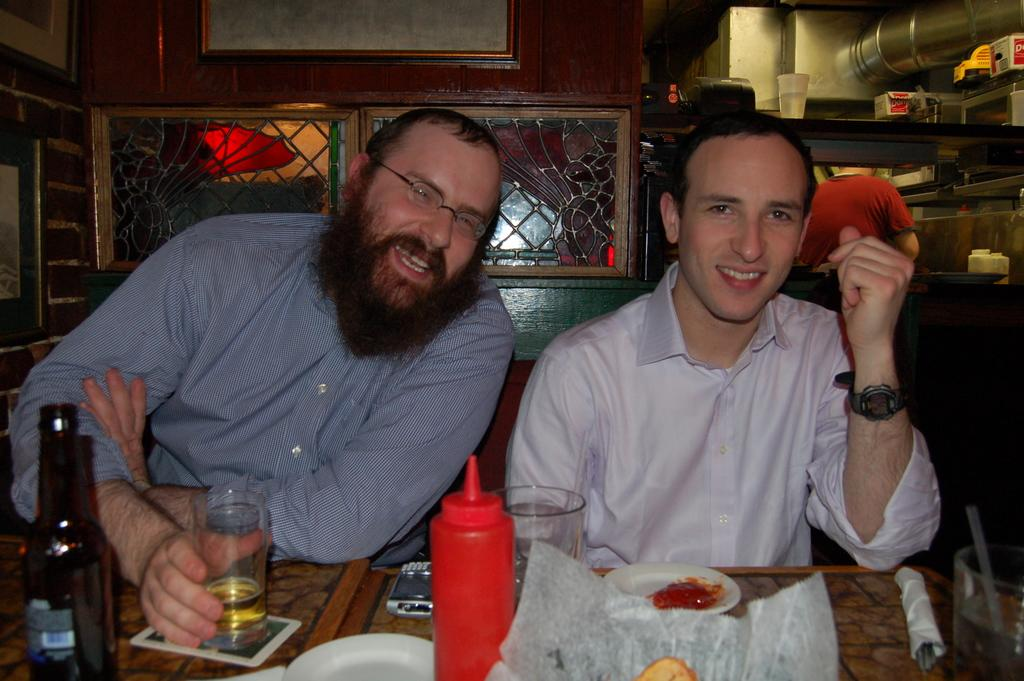How many men are in the image? There are two men in the image. What are the men doing in the image? The men are sitting and smiling. What objects can be seen on the table in the image? There are two glasses, a bottle, and a plate on the table. What can be seen in the background of the image? There is a wooden wall, a pole, and a glass in the background. What type of judgment is the judge making in the image? There is no judge present in the image, so it is not possible to determine what judgment might be made. 